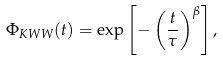<formula> <loc_0><loc_0><loc_500><loc_500>\Phi _ { K W W } ( t ) = \exp \left [ - \left ( \frac { t } { \tau } \right ) ^ { \beta } \right ] ,</formula> 